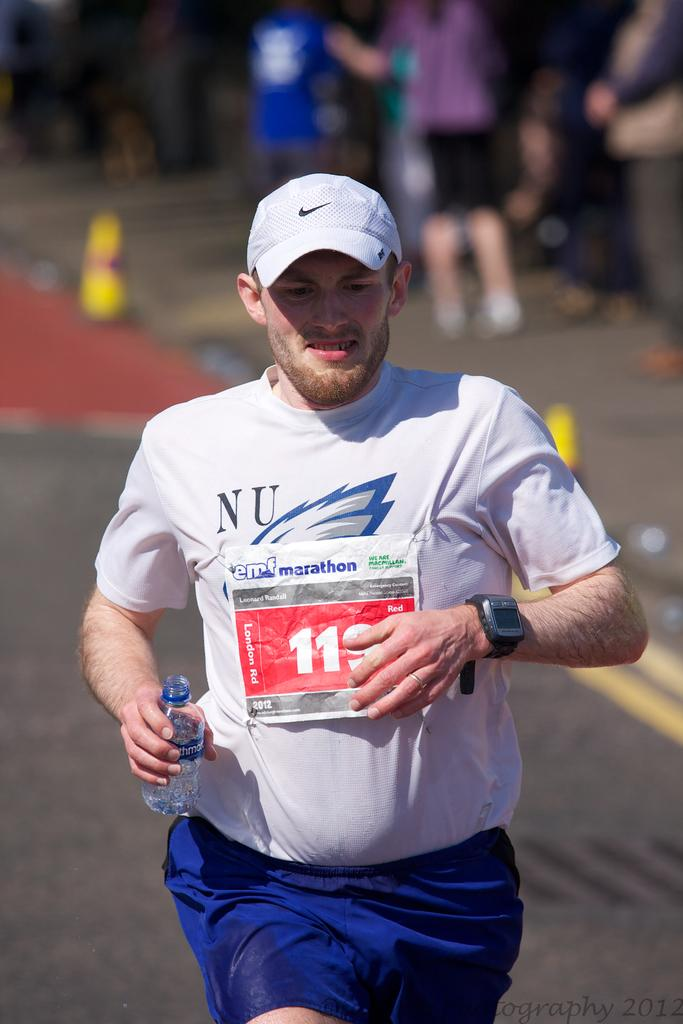What is the person in the image holding? The person is holding a bottle in the image. What is the person doing with the bottle? The person is running while holding the bottle. Can you describe the people behind the running person? There are other people behind the running person in the image. What objects are present in the image besides the people? There are traffic cones in the image. How would you describe the background of the image? The background of the image is blurred. What type of box is being used to treat the disease in the image? There is no box or disease present in the image; it features a person running while holding a bottle and other people behind them. 